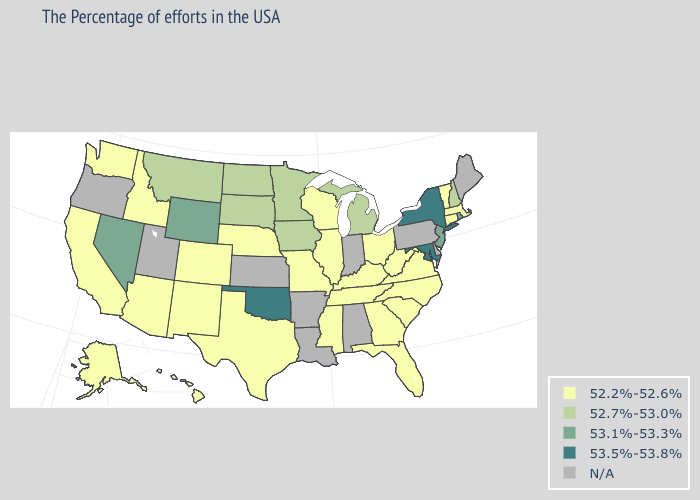How many symbols are there in the legend?
Quick response, please. 5. What is the value of Oregon?
Quick response, please. N/A. Name the states that have a value in the range 53.1%-53.3%?
Keep it brief. Rhode Island, New Jersey, Wyoming, Nevada. What is the value of Maine?
Answer briefly. N/A. What is the value of Wisconsin?
Answer briefly. 52.2%-52.6%. Name the states that have a value in the range 53.5%-53.8%?
Keep it brief. New York, Maryland, Oklahoma. What is the value of New York?
Quick response, please. 53.5%-53.8%. What is the value of Minnesota?
Concise answer only. 52.7%-53.0%. Does Virginia have the highest value in the USA?
Short answer required. No. Name the states that have a value in the range 53.1%-53.3%?
Short answer required. Rhode Island, New Jersey, Wyoming, Nevada. Does Wyoming have the highest value in the West?
Concise answer only. Yes. What is the lowest value in the USA?
Answer briefly. 52.2%-52.6%. Which states have the lowest value in the South?
Short answer required. Virginia, North Carolina, South Carolina, West Virginia, Florida, Georgia, Kentucky, Tennessee, Mississippi, Texas. Does the map have missing data?
Be succinct. Yes. 